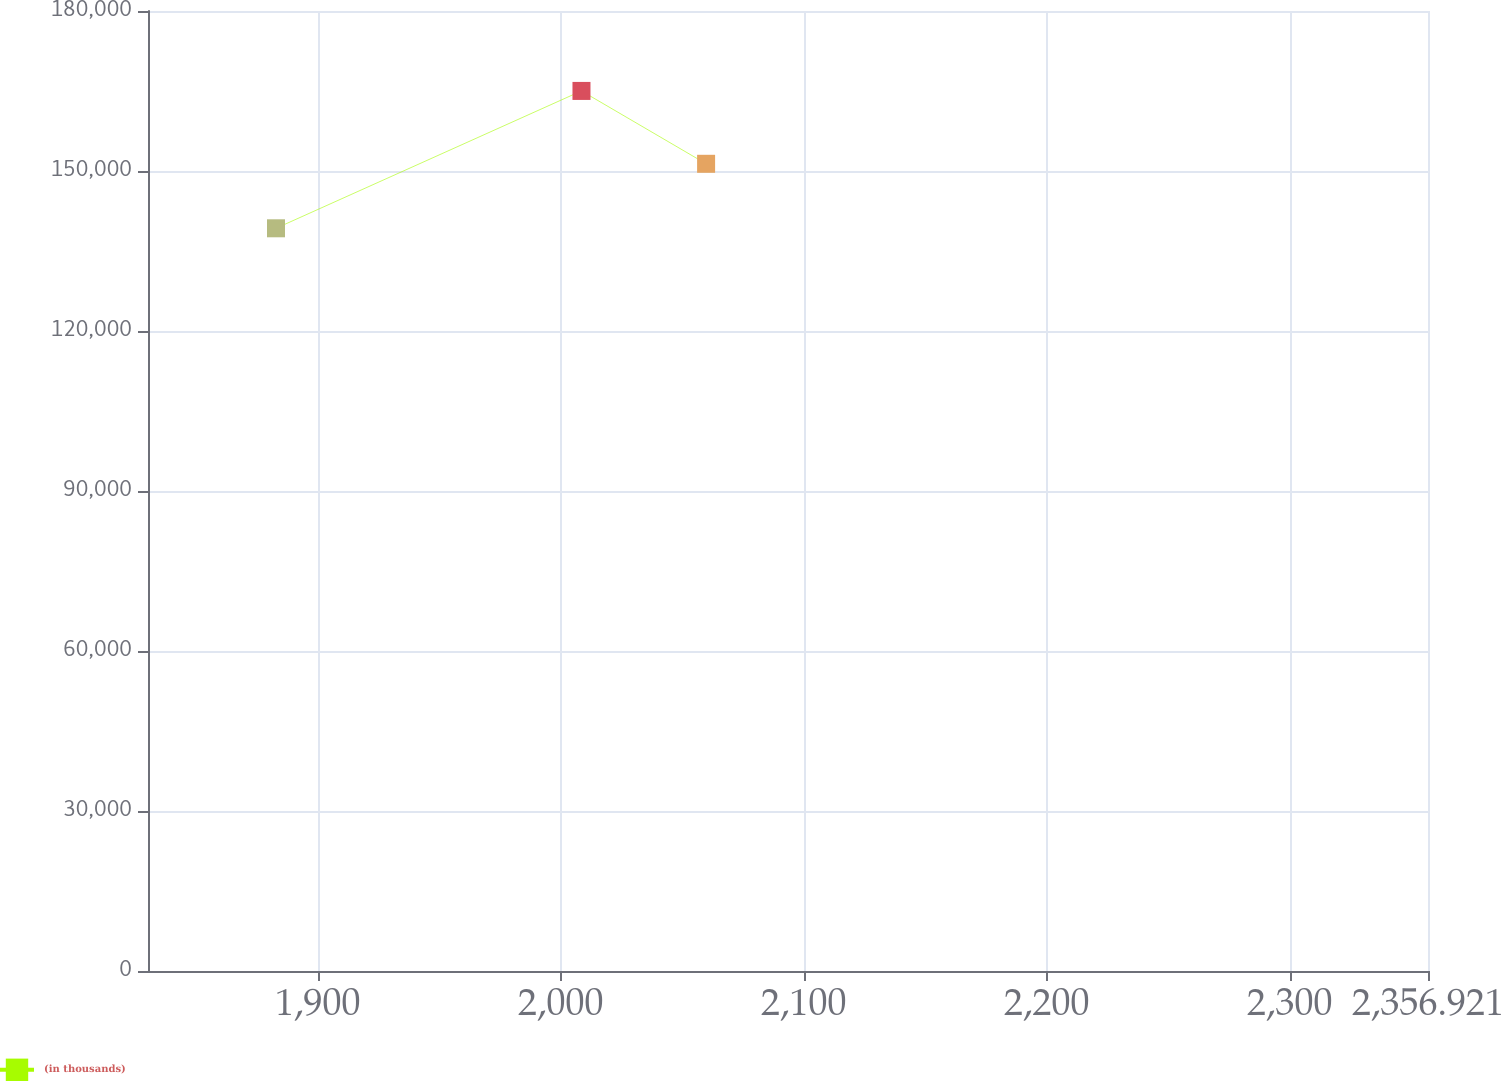<chart> <loc_0><loc_0><loc_500><loc_500><line_chart><ecel><fcel>(in thousands)<nl><fcel>1882.81<fcel>139258<nl><fcel>2008.53<fcel>165014<nl><fcel>2059.82<fcel>151351<nl><fcel>2358.31<fcel>143112<nl><fcel>2409.6<fcel>126467<nl></chart> 